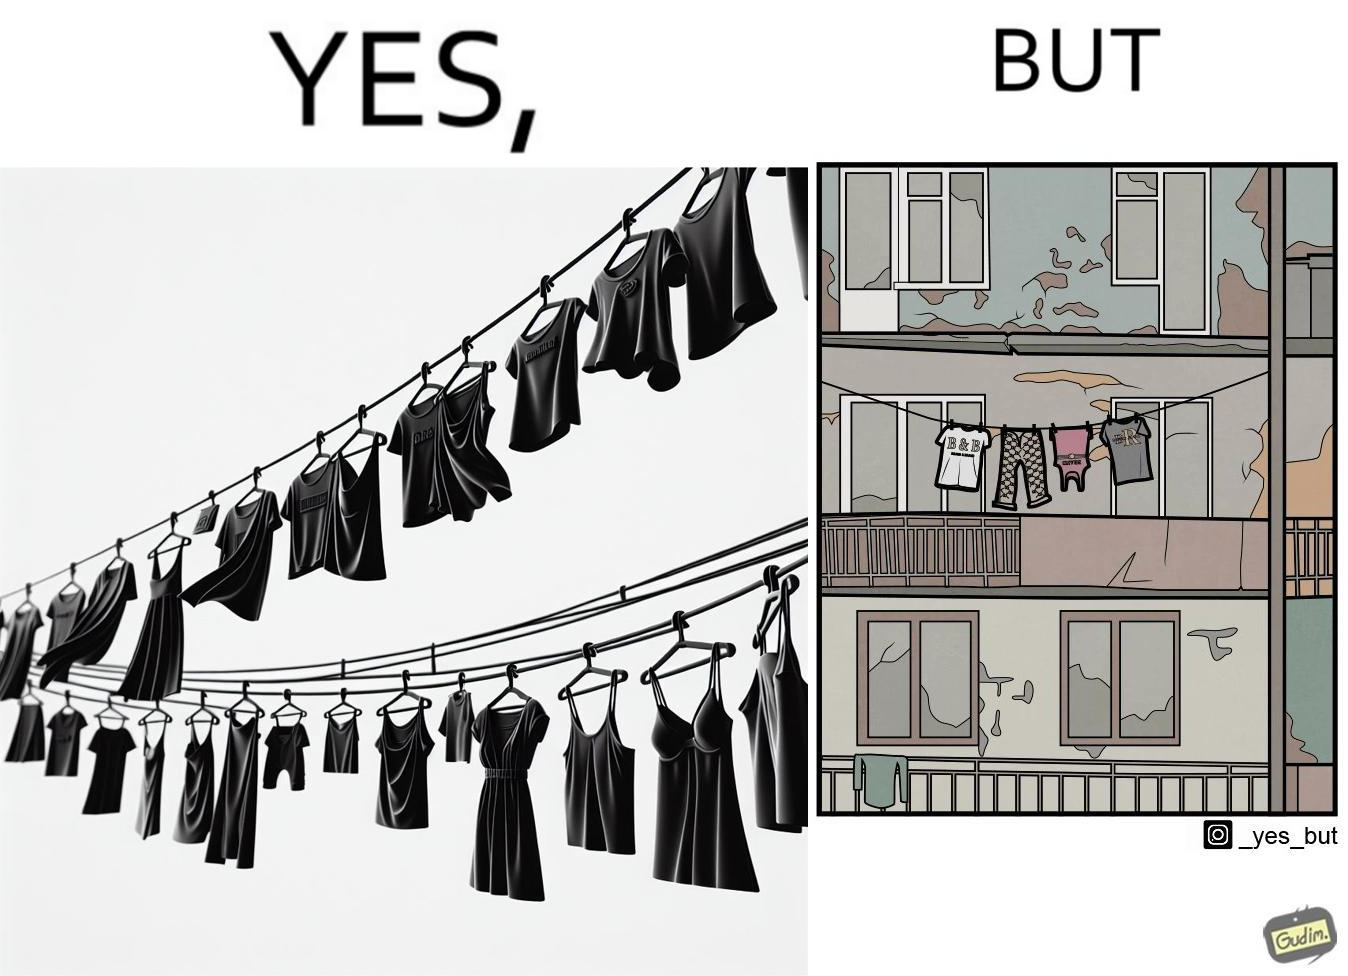Does this image contain satire or humor? Yes, this image is satirical. 